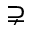Convert formula to latex. <formula><loc_0><loc_0><loc_500><loc_500>\supsetneq</formula> 